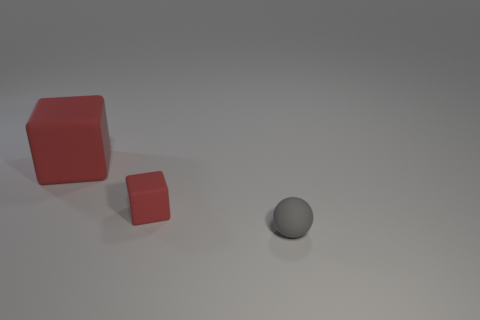Add 3 big brown matte blocks. How many objects exist? 6 Subtract all blocks. How many objects are left? 1 Subtract 1 spheres. How many spheres are left? 0 Subtract 0 blue cylinders. How many objects are left? 3 Subtract all yellow cubes. Subtract all brown cylinders. How many cubes are left? 2 Subtract all red cylinders. How many brown balls are left? 0 Subtract all small spheres. Subtract all cubes. How many objects are left? 0 Add 1 small gray matte balls. How many small gray matte balls are left? 2 Add 1 red things. How many red things exist? 3 